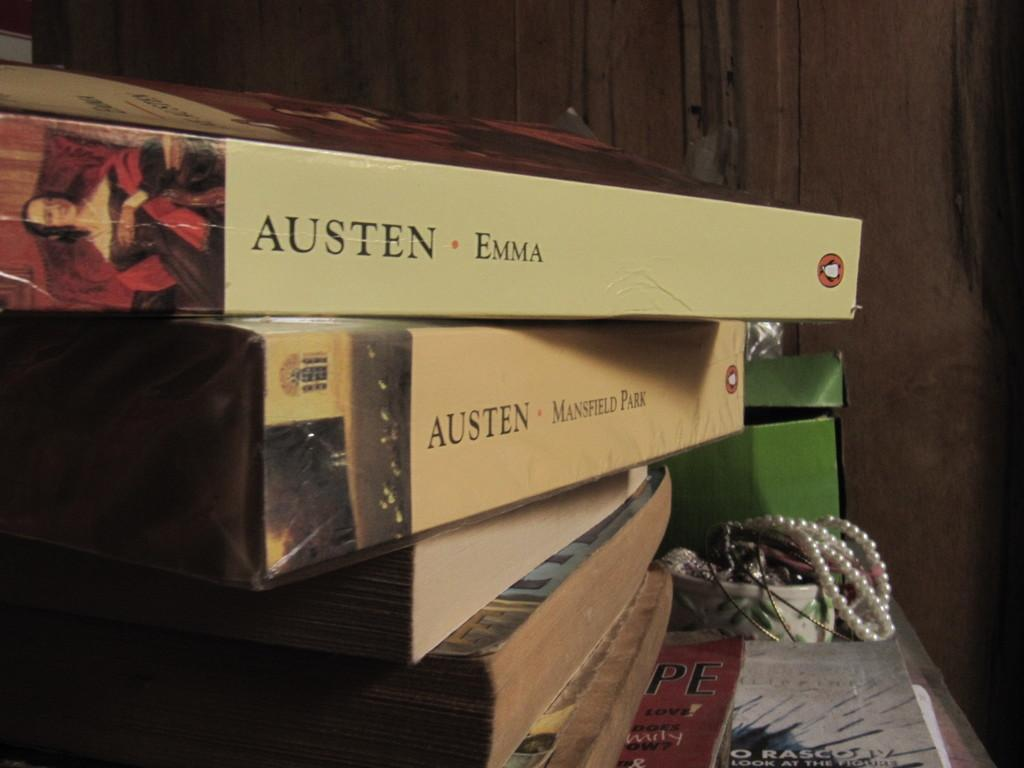<image>
Relay a brief, clear account of the picture shown. Two Jane Austen novels are stacked on other books. 